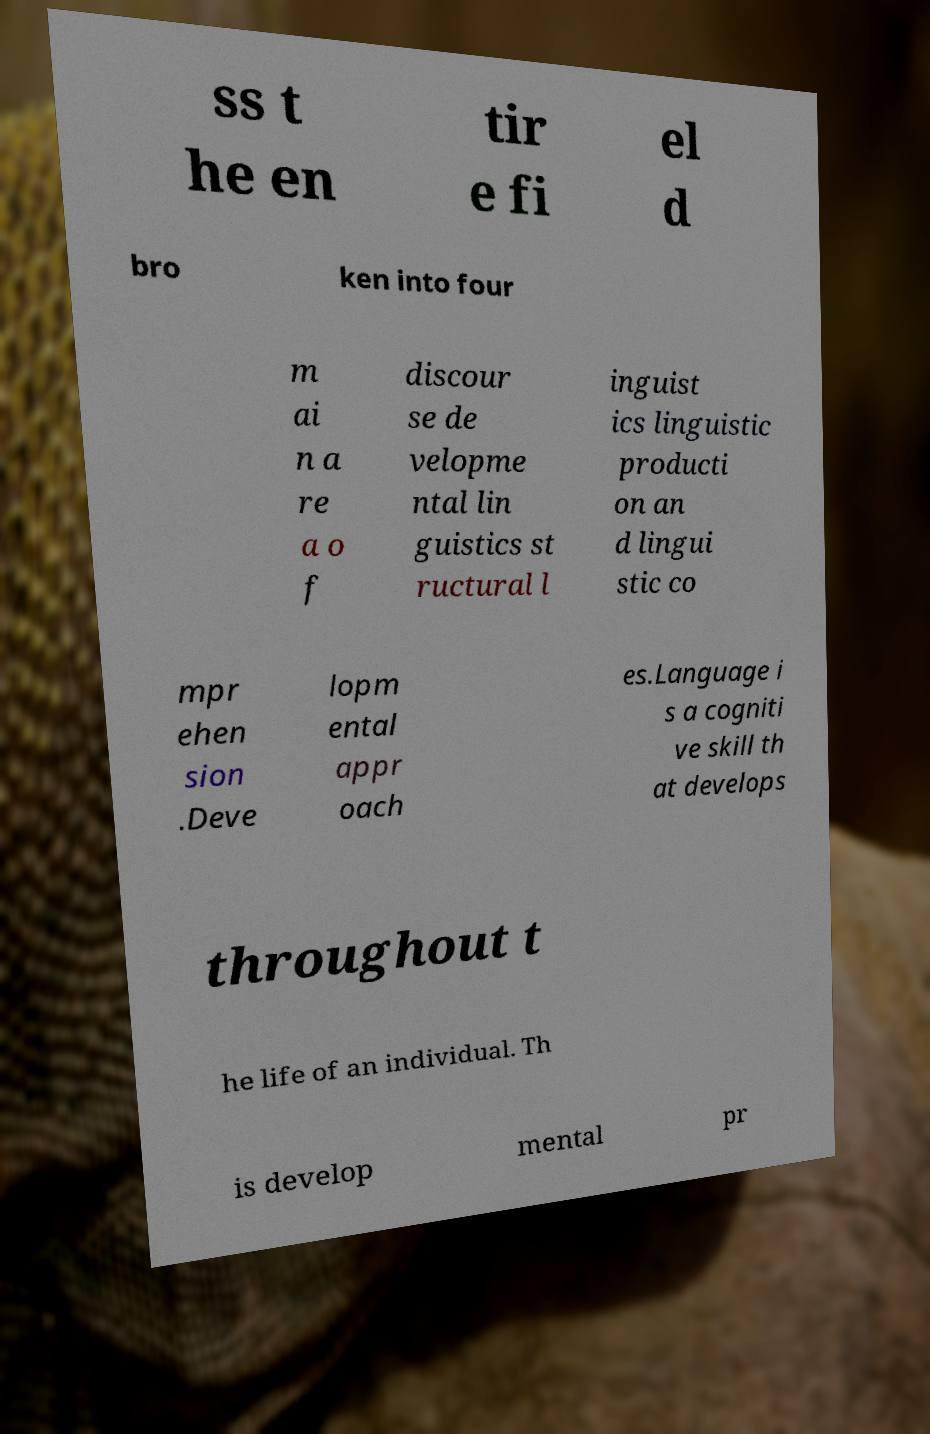Please read and relay the text visible in this image. What does it say? ss t he en tir e fi el d bro ken into four m ai n a re a o f discour se de velopme ntal lin guistics st ructural l inguist ics linguistic producti on an d lingui stic co mpr ehen sion .Deve lopm ental appr oach es.Language i s a cogniti ve skill th at develops throughout t he life of an individual. Th is develop mental pr 